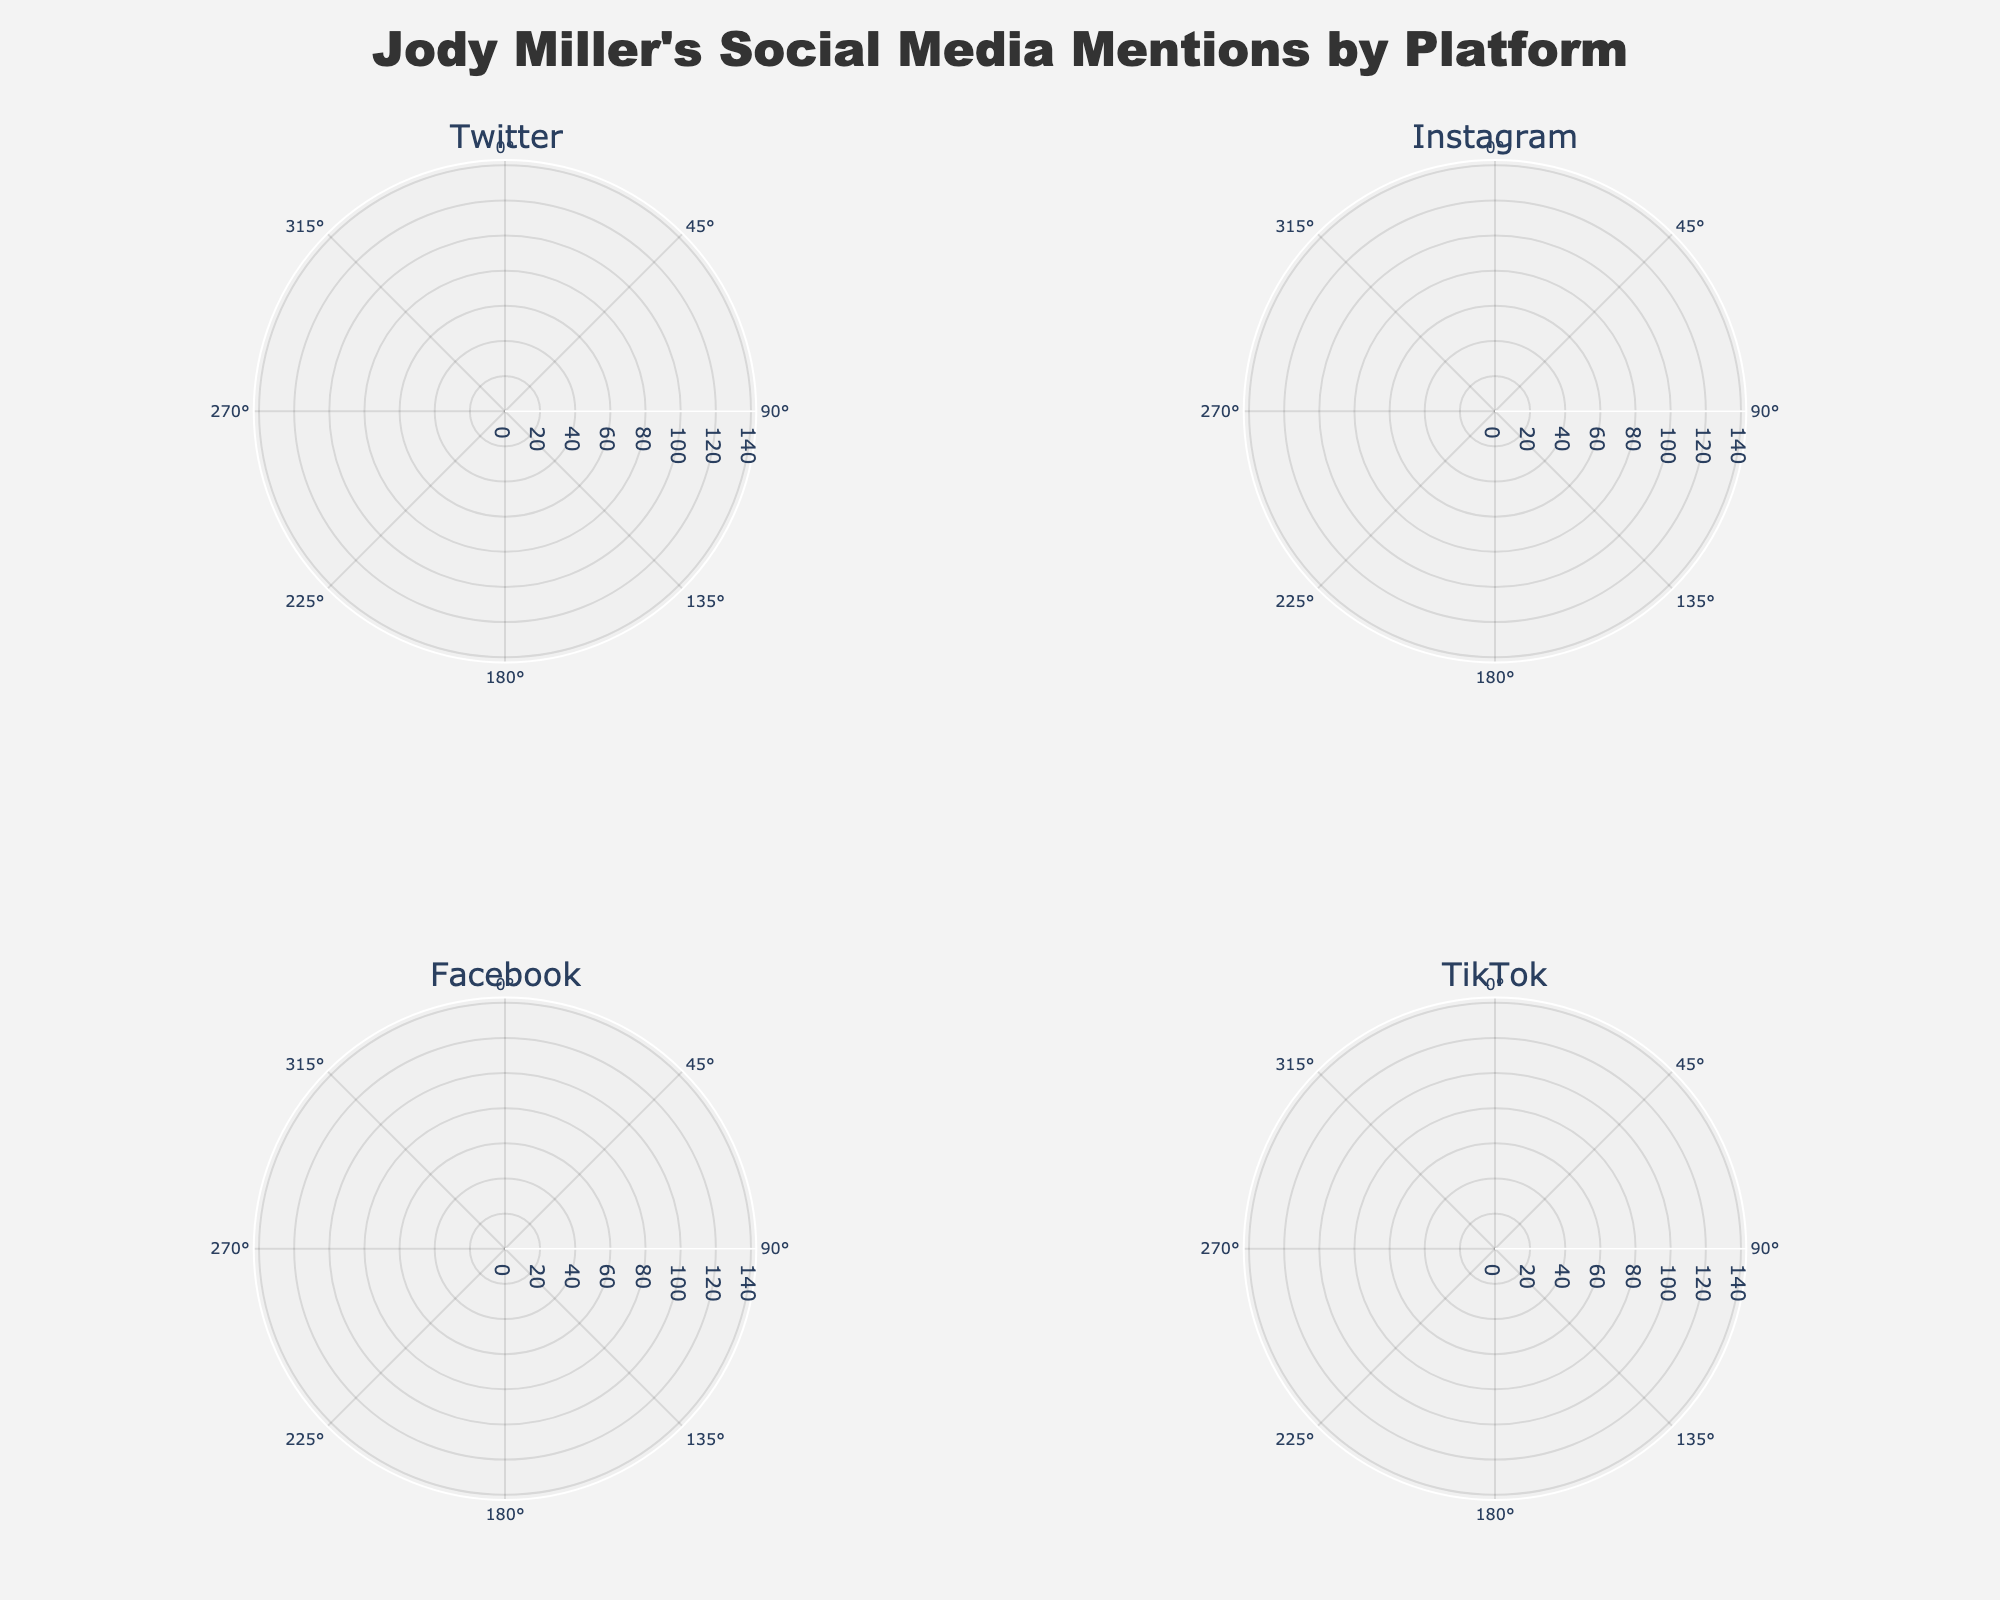what is the title of the figure? The title is typically placed at the top of the figure, in the center, and is clearly marked. In this case, the title provided in the code is visible on the figure as well.
Answer: "Jody Miller's Social Media Mentions by Platform" what is the maximum mentions count for TikTok? Look for the data points on the polar chart subplot for TikTok and find the point that represents the highest mentions count on the radial axis.
Answer: 110 how many platforms are plotted in the subplots? The subplot titles or legends should indicate the different platforms plotted in the subplots. Here, it mentions Twitter, Instagram, Facebook, and TikTok.
Answer: 4 which platform saw the highest peak in mentions over the year? Compare the highest peaks of mentions in each polar plot. TikTok reaches up to 110, Instagram reaches 130, Twitter reaches 90, and Facebook reaches 100. Instagram has the highest peak.
Answer: Instagram during which month did TikTok see a significant rise in mentions compared to previous months? Observe the data points for TikTok to identify the month where there is a visible significant increase compared to earlier data points. There is a noticeable rise between April and May.
Answer: May which platform shows the most consistent increase in mentions over the year? Look at the lines plotted in each subplot. The platform that shows a steady increase month by month without any sharp drops shows consistent growth.
Answer: Instagram what is the mention count difference for Twitter between January and August? Identify the mention counts for Twitter in January and August on the respective polar chart. January has 55 mentions and August has 85 mentions. Subtract January's mentions from August's.
Answer: 30 what is the range of mentions for Facebook from January to October? Identify the minimum and maximum mentions count for Facebook within the plot. The minimum is 35 (January), and the maximum is 100 (October). Subtract the minimum from the maximum to get the range.
Answer: 65 which month experienced the highest mentions across all platforms? Compare the data points for all platforms for each month to see which month has the highest value across any platform.
Answer: October how do the mention trends of Twitter and Instagram compare across the year? By examining the shapes of the plots for Twitter and Instagram, you can determine that Twitter experiences more fluctuation, whereas Instagram shows a consistent upward trend.
Answer: Twitter fluctuates, Instagram rises consistently 